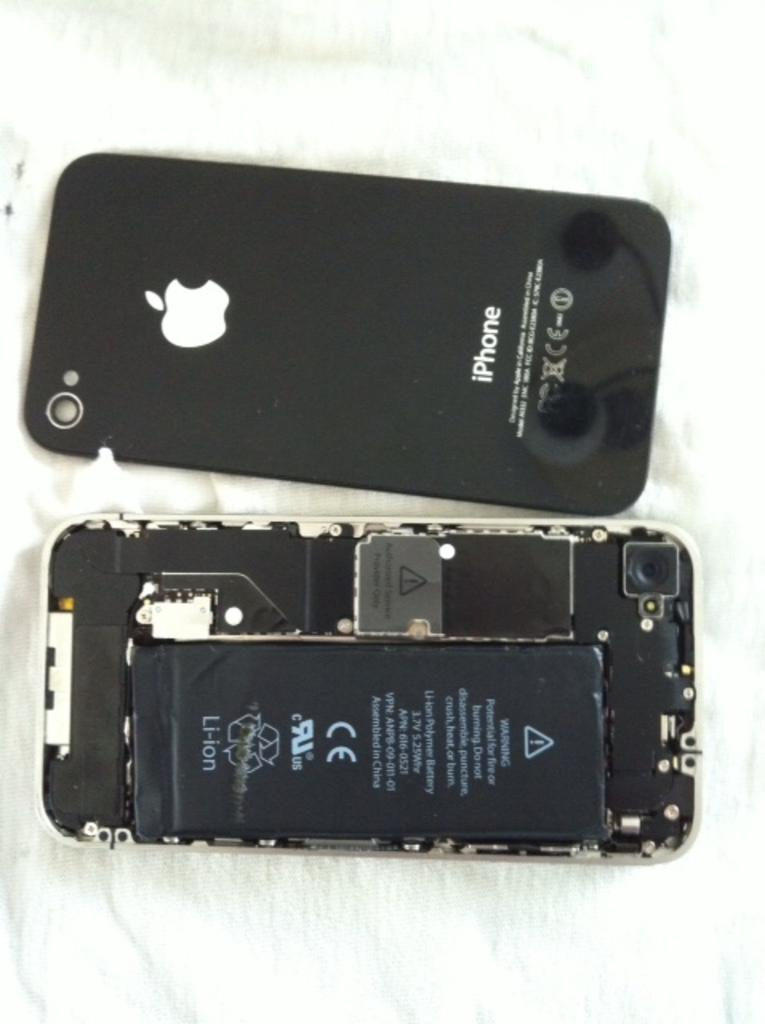Provide a one-sentence caption for the provided image. An iPhone is shown with and without the back cover removed to show the lithium ion battery. 